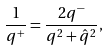Convert formula to latex. <formula><loc_0><loc_0><loc_500><loc_500>\frac { 1 } { q ^ { + } } = \frac { 2 q ^ { - } } { q ^ { 2 } + \hat { q } ^ { 2 } } ,</formula> 